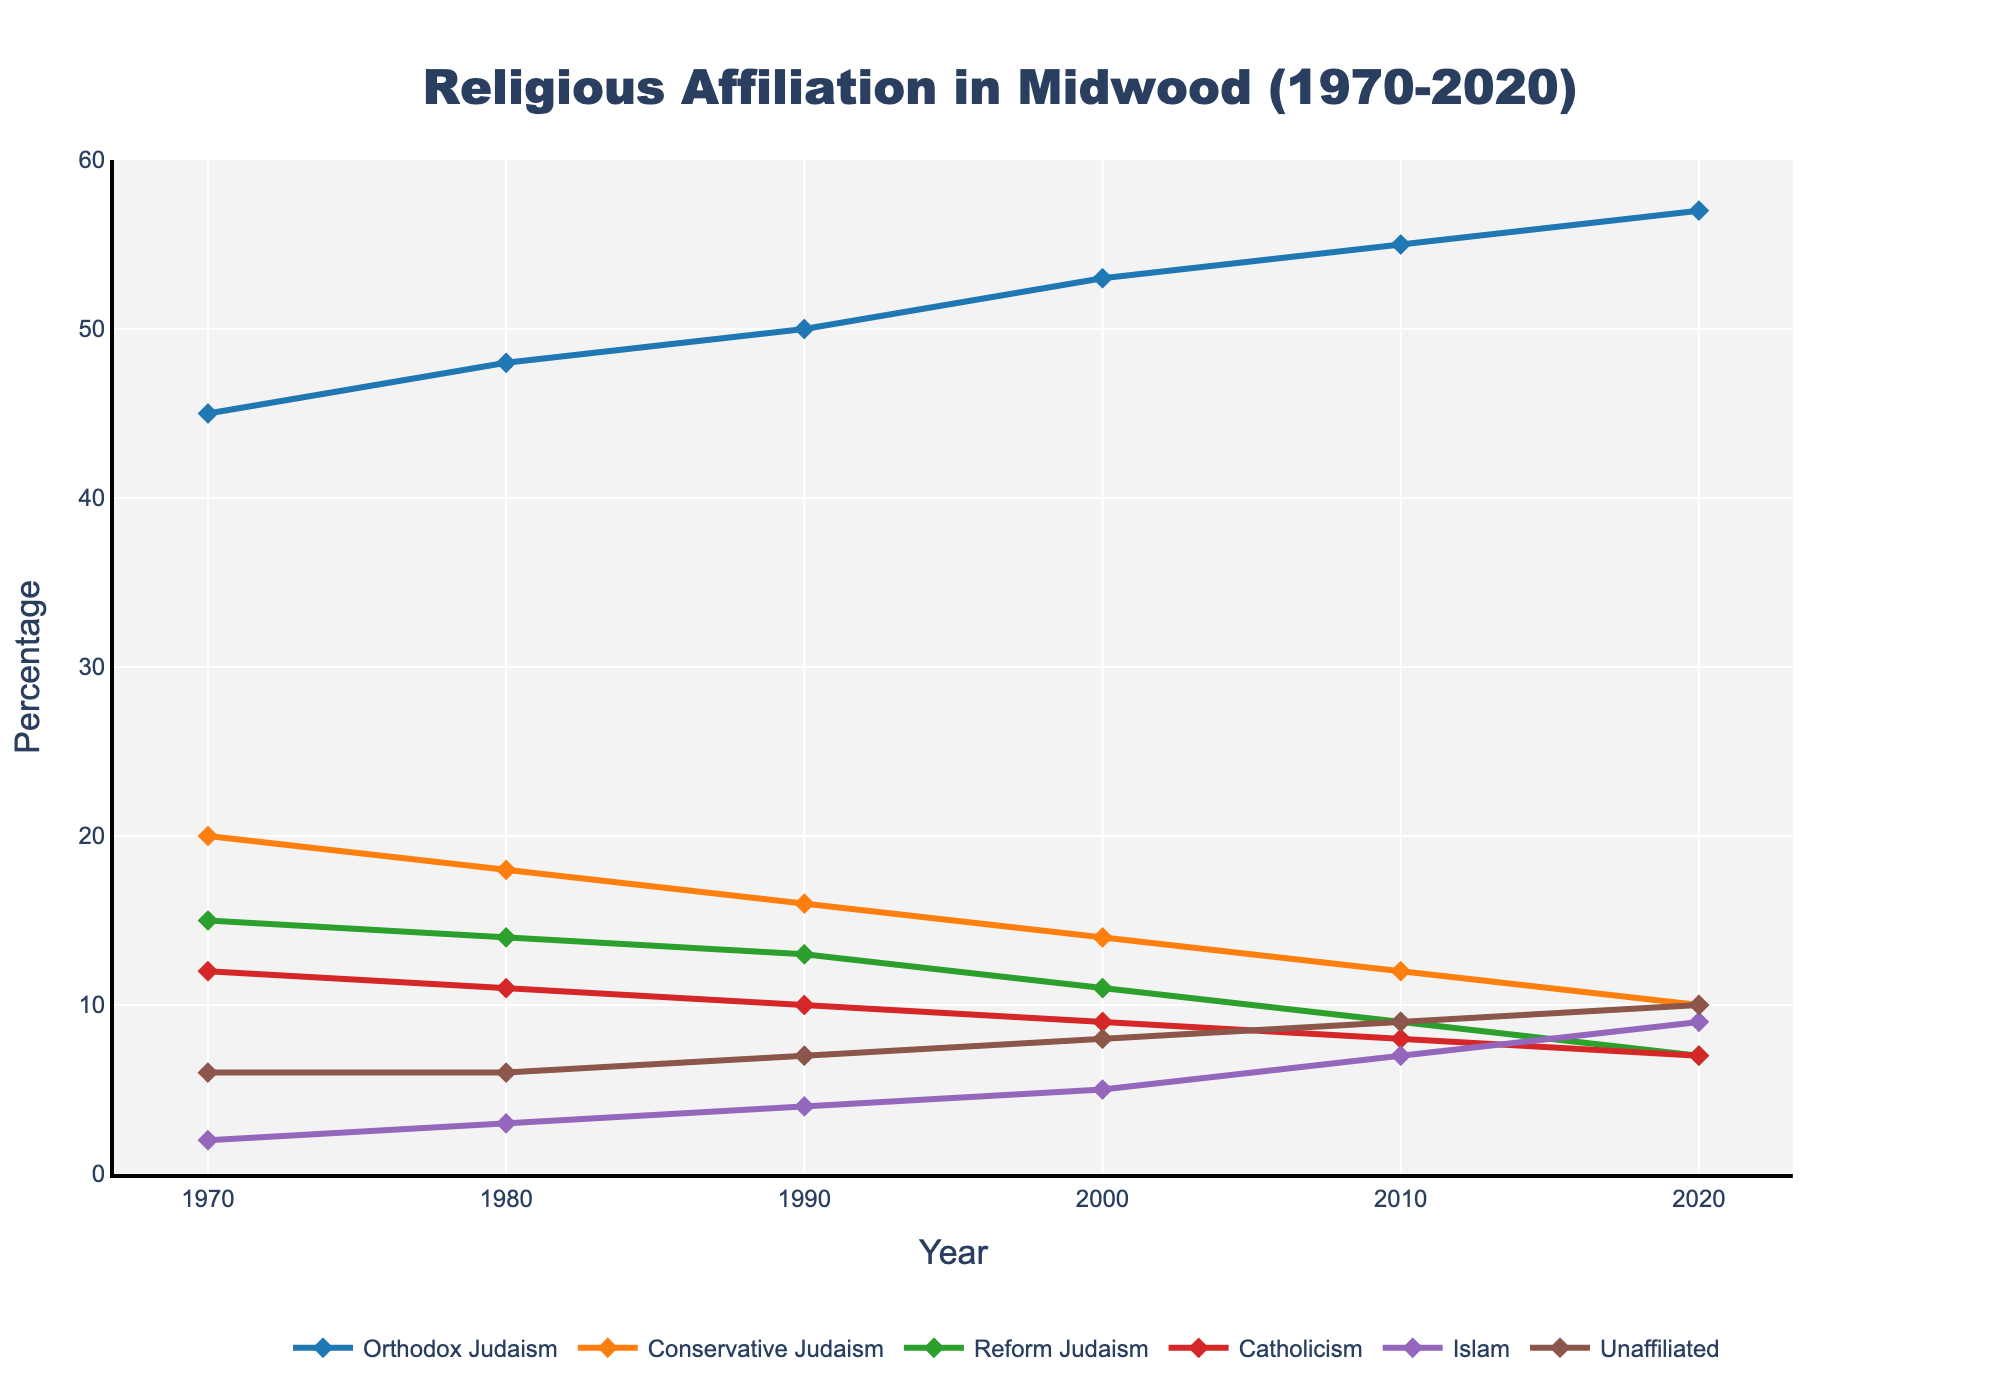Which religious affiliation had the highest percentage in 2020? The figure shows that Orthodox Judaism had the highest percentage among all religious affiliations in 2020.
Answer: Orthodox Judaism How did the percentage of Reform Judaism change from 1970 to 2020? In 1970, Reform Judaism was at 15%, and in 2020, it was at 7%. The percentage decreased by 8%.
Answer: Decreased by 8% Between which consecutive decades did Islam see the largest increase in its percentage? By analyzing the chart, the largest increase for Islam occurred between 2000 and 2010, where it went from 5% to 7%, a 2% increase.
Answer: 2000 to 2010 Which group had the largest decline in its percentage over the entire 50-year period? Conservative Judaism’s percentage decreased from 20% in 1970 to 10% in 2020, which is a decline of 10%. No other group showed a decline this large.
Answer: Conservative Judaism How did the unaffiliated group's percentage change from 1970 to 2020? Unaffiliated percentages increased from 6% in 1970 to 10% in 2020, a total increase of 4%.
Answer: Increased by 4% Which two religious affiliations had converging percentages by the year 2020? By 2020, Catholicism and Islam both had percentages of 7%, indicating convergence.
Answer: Catholicism and Islam From 1980 to 1990, which group had the smallest change in percentage? The unaffiliated group had the smallest change, remaining constant at 6%.
Answer: Unaffiliated Comparing 1970 and 2020, which group showed the highest increase in its percentage? Orthodox Judaism increased from 45% in 1970 to 57% in 2020, which is an increase of 12%, the highest among all groups.
Answer: Orthodox Judaism If you average the percentage of Catholicism over all available years, what would it be? The years are 1970 (12%), 1980 (11%), 1990 (10%), 2000 (9%), 2010 (8%), and 2020 (7%). The sum is 57%, and the average is 57/6 ≈ 9.5%.
Answer: 9.5% Between which two decades did Conservative Judaism see the most significant drop? Conservative Judaism dropped from 16% in 1990 to 14% in 2000, which is a 2% decline, the most significant of all other decade changes.
Answer: 1990 to 2000 